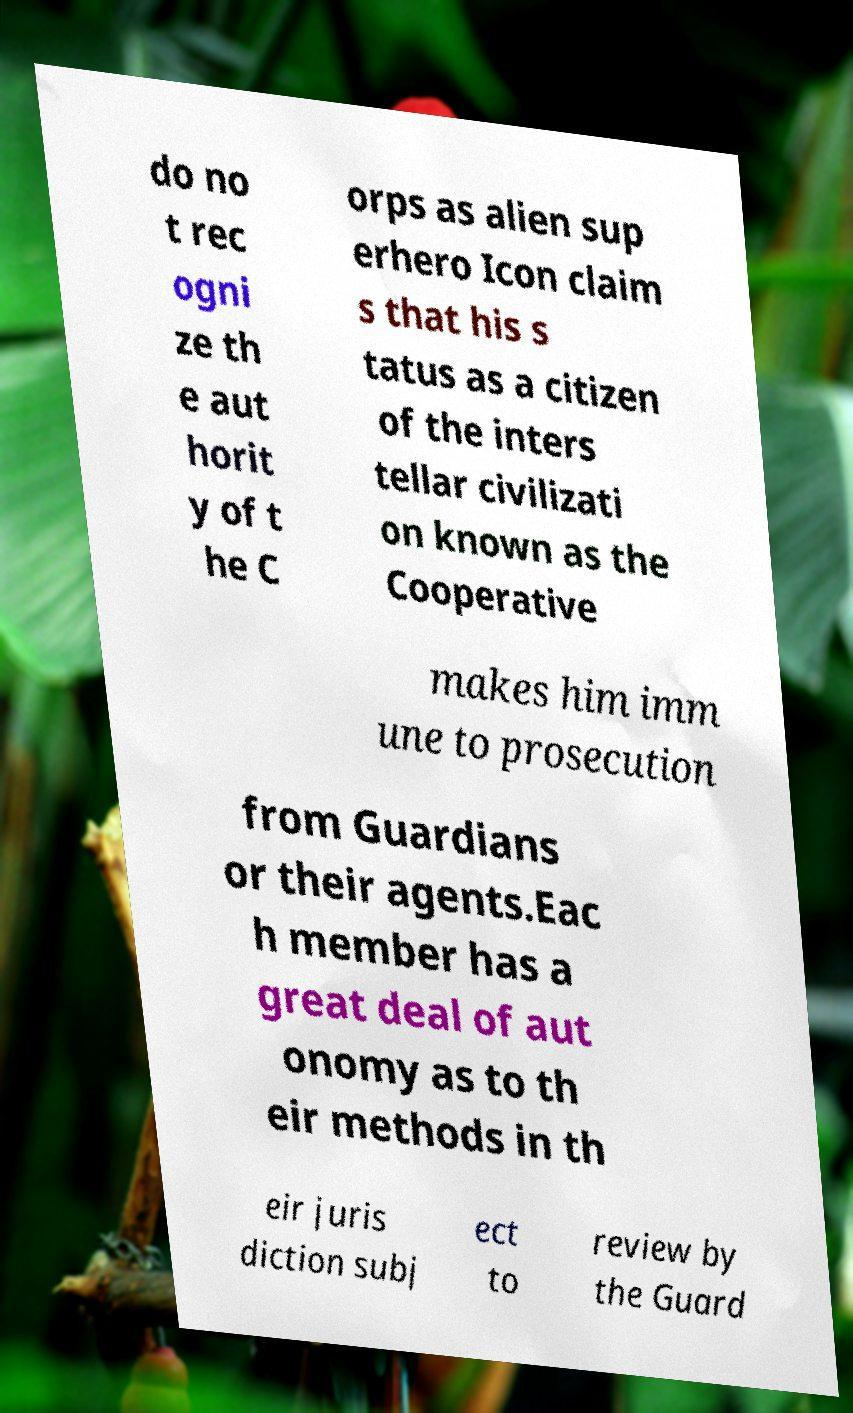For documentation purposes, I need the text within this image transcribed. Could you provide that? do no t rec ogni ze th e aut horit y of t he C orps as alien sup erhero Icon claim s that his s tatus as a citizen of the inters tellar civilizati on known as the Cooperative makes him imm une to prosecution from Guardians or their agents.Eac h member has a great deal of aut onomy as to th eir methods in th eir juris diction subj ect to review by the Guard 